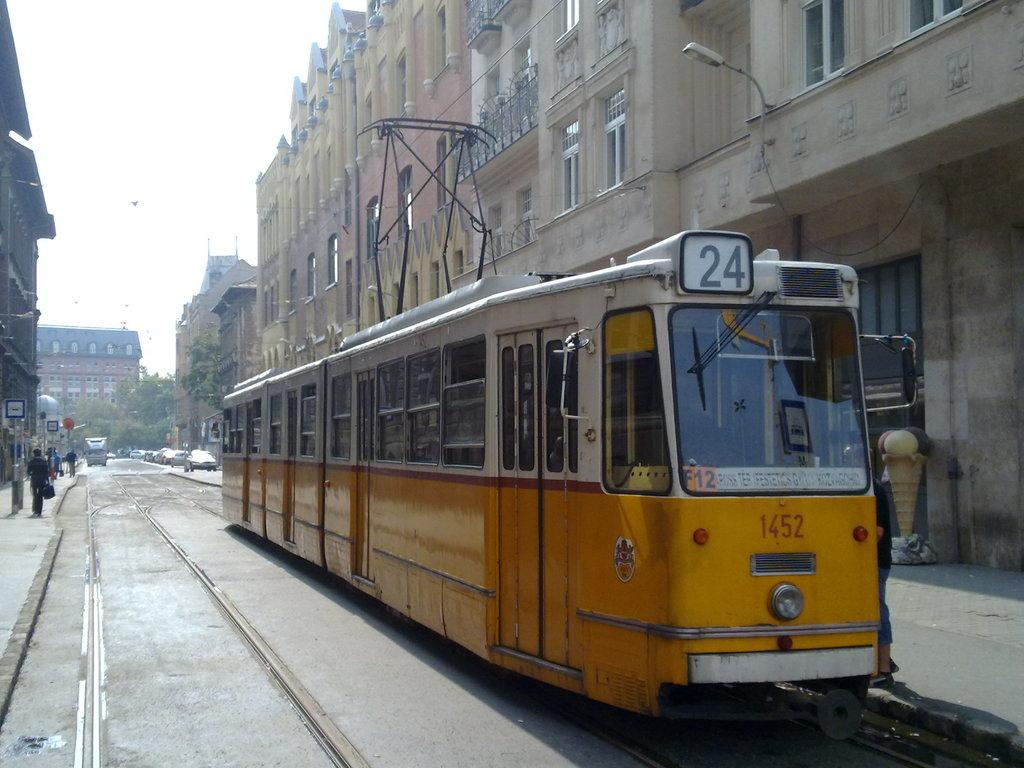<image>
Give a short and clear explanation of the subsequent image. A yellow train with 24 written on the top rides through a town 